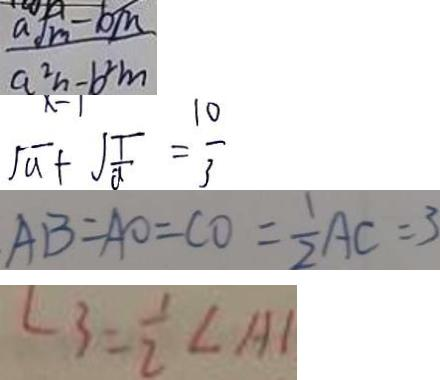<formula> <loc_0><loc_0><loc_500><loc_500>\frac { a \sqrt { m } - b m } { a ^ { 2 } n - b ^ { 2 } m } 
 \sqrt { a } + \sqrt { \frac { 1 } { a } } = \frac { 1 0 } { 3 } 
 A B = A O = C O = \frac { 1 } { 2 } A C = 3 
 \angle 3 = \frac { 1 } { 2 } \angle A 1</formula> 